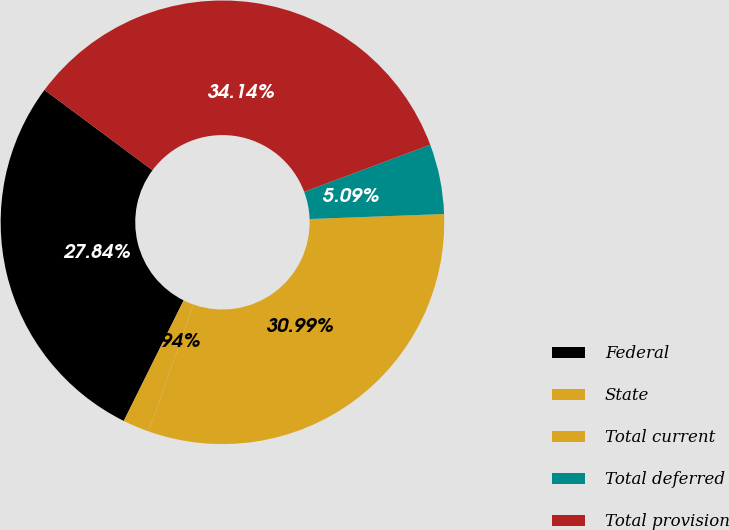<chart> <loc_0><loc_0><loc_500><loc_500><pie_chart><fcel>Federal<fcel>State<fcel>Total current<fcel>Total deferred<fcel>Total provision<nl><fcel>27.84%<fcel>1.94%<fcel>30.99%<fcel>5.09%<fcel>34.14%<nl></chart> 